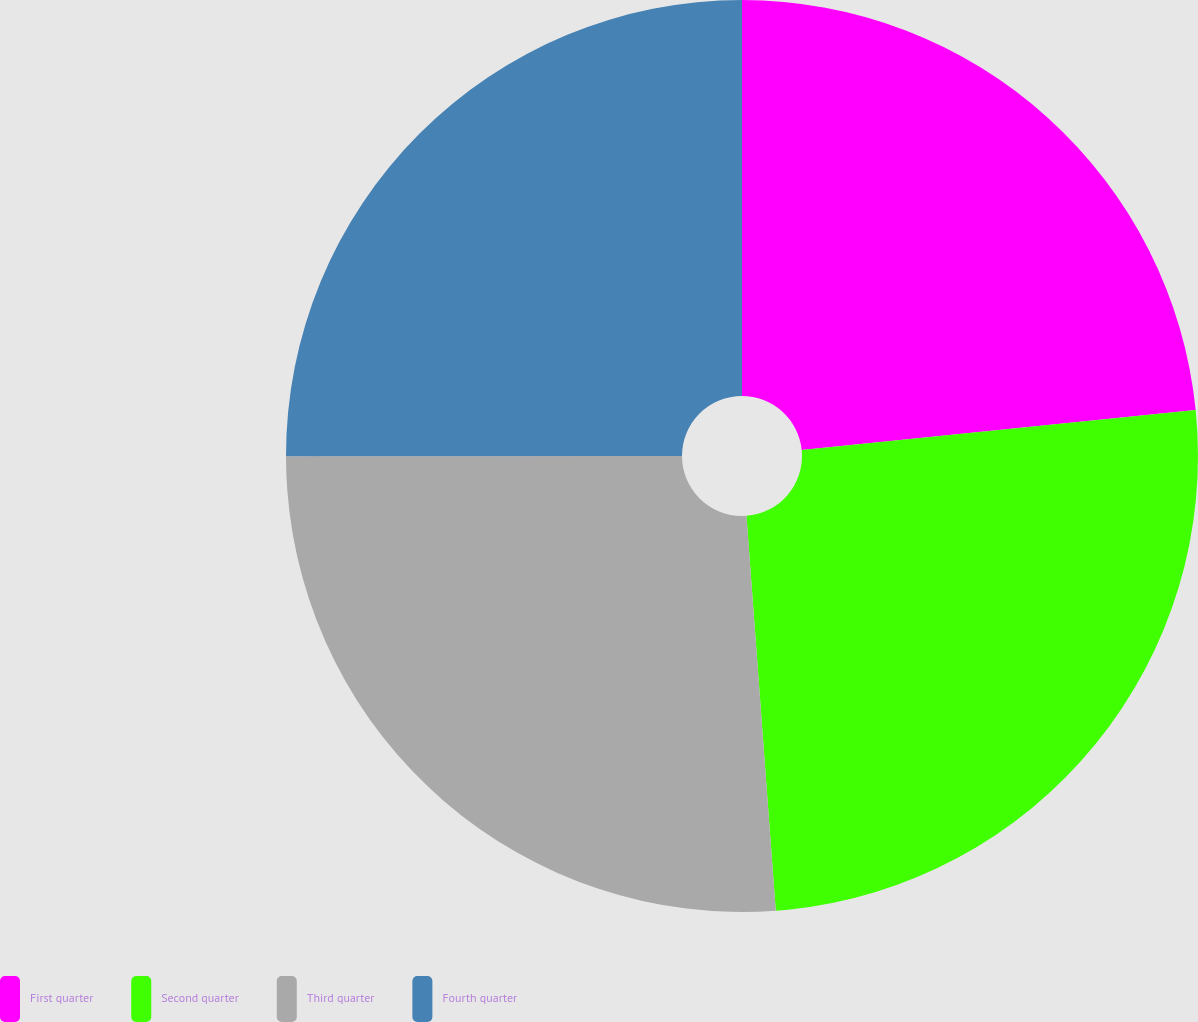Convert chart. <chart><loc_0><loc_0><loc_500><loc_500><pie_chart><fcel>First quarter<fcel>Second quarter<fcel>Third quarter<fcel>Fourth quarter<nl><fcel>23.39%<fcel>25.43%<fcel>26.17%<fcel>25.01%<nl></chart> 